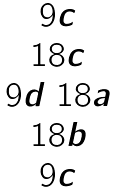Convert formula to latex. <formula><loc_0><loc_0><loc_500><loc_500>\begin{matrix} 9 c \\ 1 8 c \\ 9 d \ 1 8 a \\ 1 8 b \\ 9 c \end{matrix}</formula> 